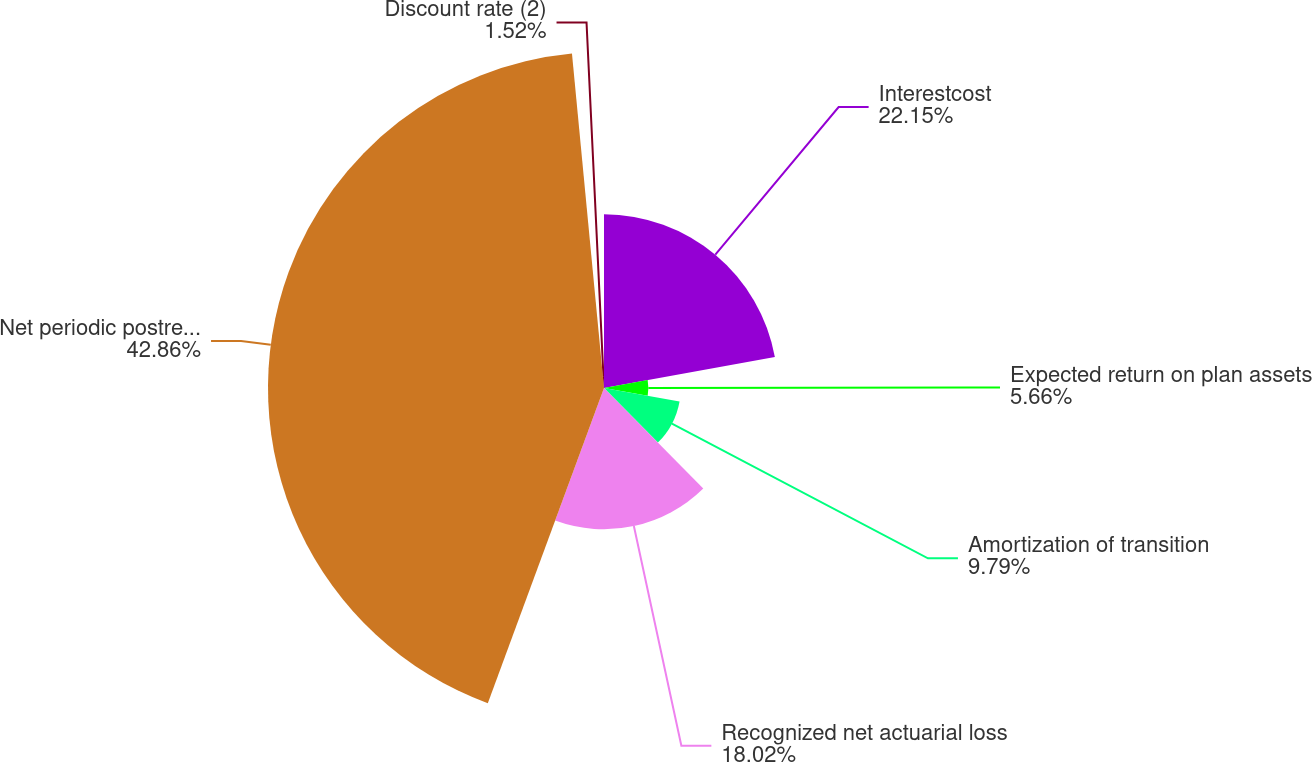<chart> <loc_0><loc_0><loc_500><loc_500><pie_chart><fcel>Interestcost<fcel>Expected return on plan assets<fcel>Amortization of transition<fcel>Recognized net actuarial loss<fcel>Net periodic postretirement<fcel>Discount rate (2)<nl><fcel>22.15%<fcel>5.66%<fcel>9.79%<fcel>18.02%<fcel>42.86%<fcel>1.52%<nl></chart> 